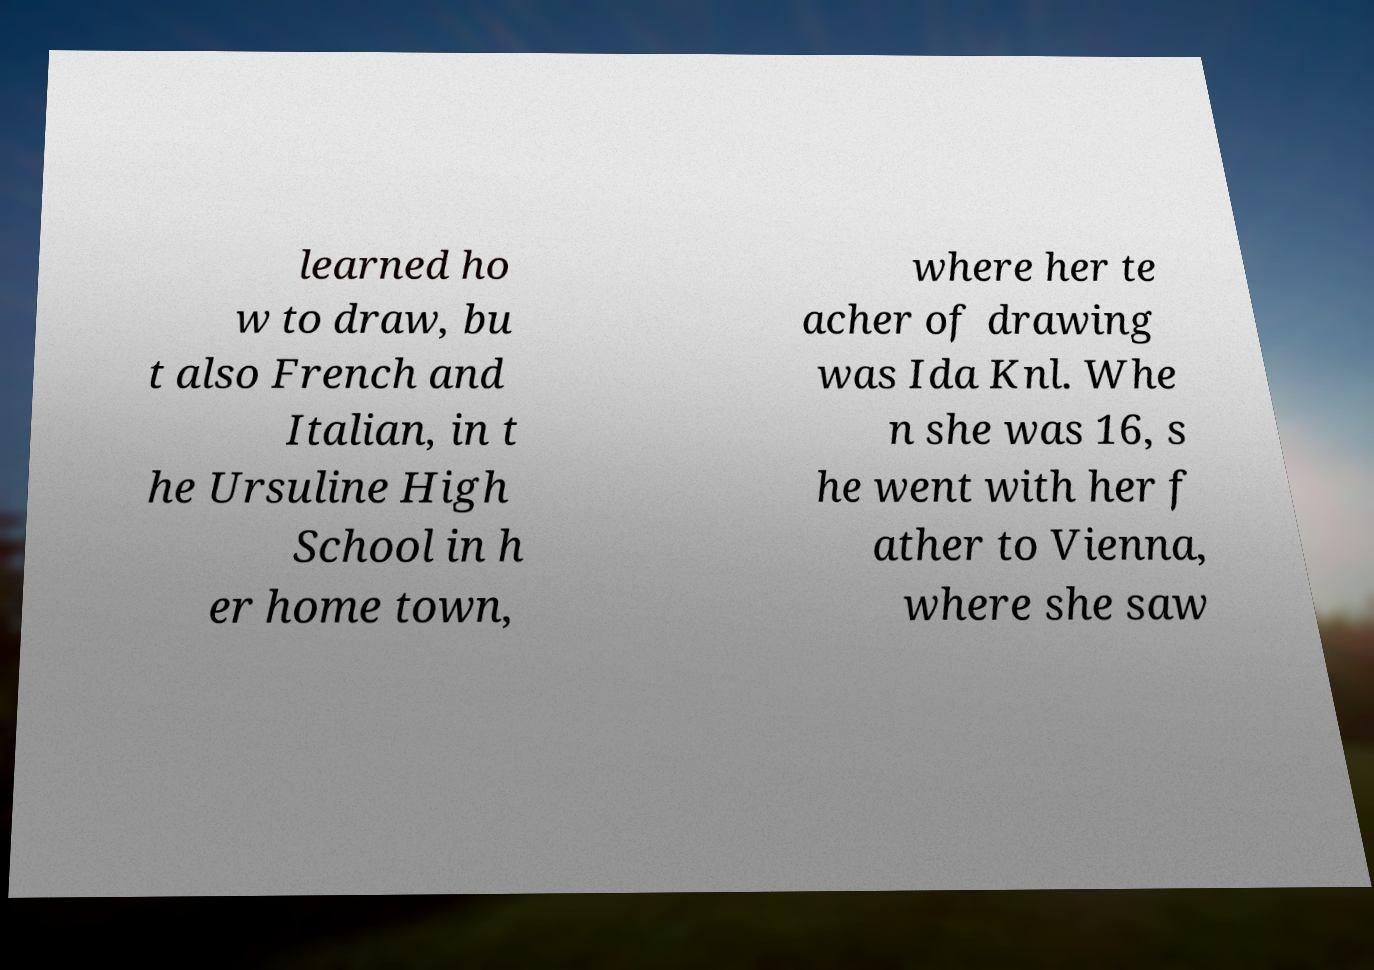Could you assist in decoding the text presented in this image and type it out clearly? learned ho w to draw, bu t also French and Italian, in t he Ursuline High School in h er home town, where her te acher of drawing was Ida Knl. Whe n she was 16, s he went with her f ather to Vienna, where she saw 